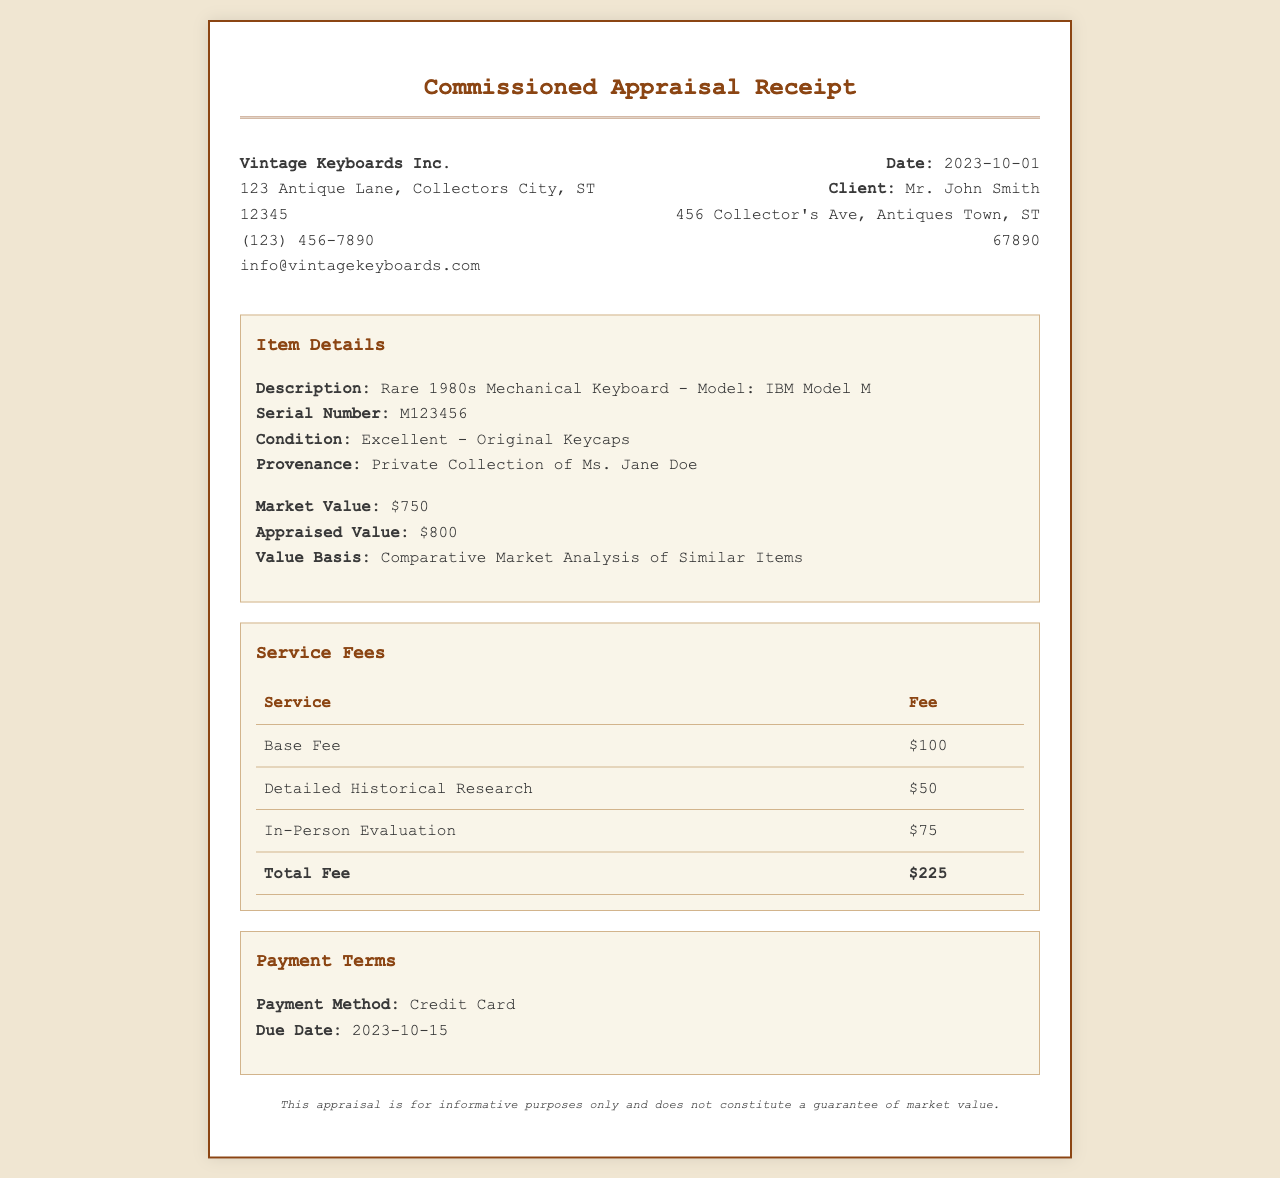What is the date of the receipt? The date is specified in the header section of the receipt as the date the appraisal was commissioned.
Answer: 2023-10-01 What is the client's name? The client's name is provided in the header section of the receipt where client information is listed.
Answer: Mr. John Smith What is the appraised value of the keyboard? The appraised value is mentioned in the item details section, indicating the valuation of the keyboard.
Answer: $800 How much is the total fee for the services? The total fee is listed under the service fees section, summarizing all service charges.
Answer: $225 What is the payment method? The payment method is specified in the payment terms section of the receipt.
Answer: Credit Card What model is the 1980s mechanical keyboard? The model of the keyboard is indicated in the item details section, describing its specific type.
Answer: IBM Model M How much is the base fee for the appraisal service? The base fee is detailed in the service fees section, indicating the charge for the appraisal service.
Answer: $100 When is the payment due? The due date for the payment is provided in the payment terms section.
Answer: 2023-10-15 What type of analysis was used for the appraised value? The basis for the appraised value is mentioned in the item details section of the receipt.
Answer: Comparative Market Analysis of Similar Items 